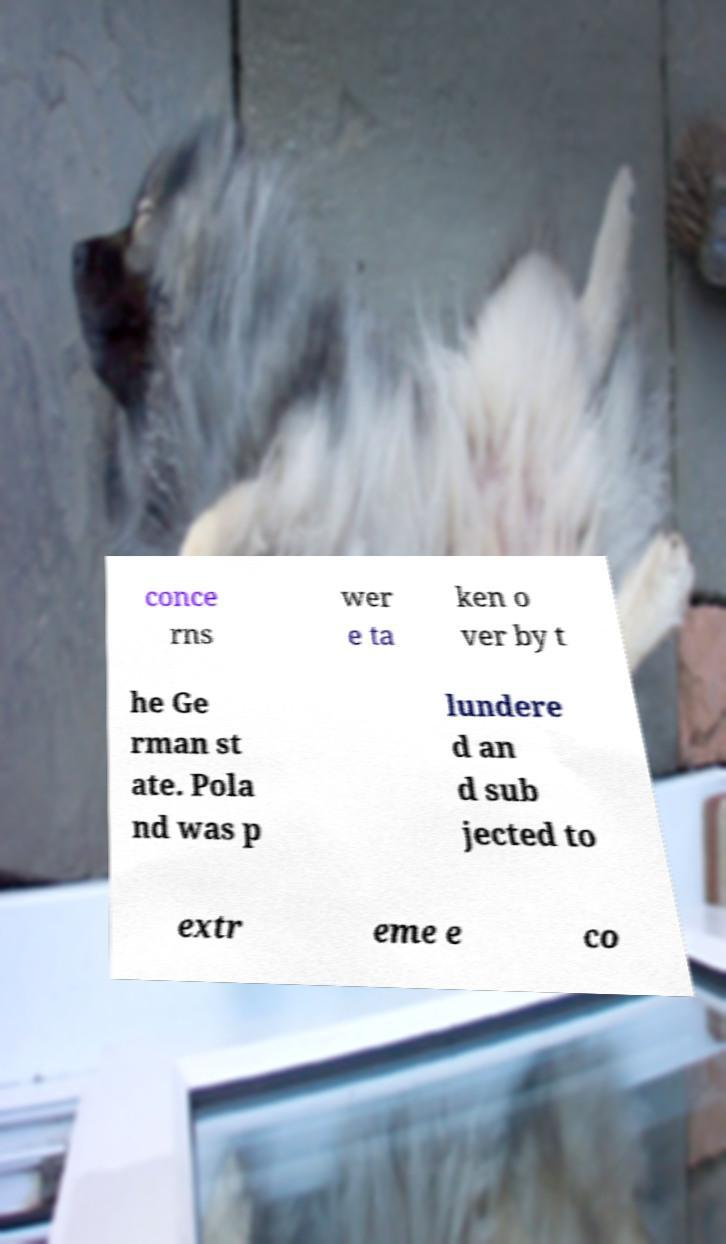Please read and relay the text visible in this image. What does it say? conce rns wer e ta ken o ver by t he Ge rman st ate. Pola nd was p lundere d an d sub jected to extr eme e co 